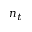Convert formula to latex. <formula><loc_0><loc_0><loc_500><loc_500>n _ { t }</formula> 